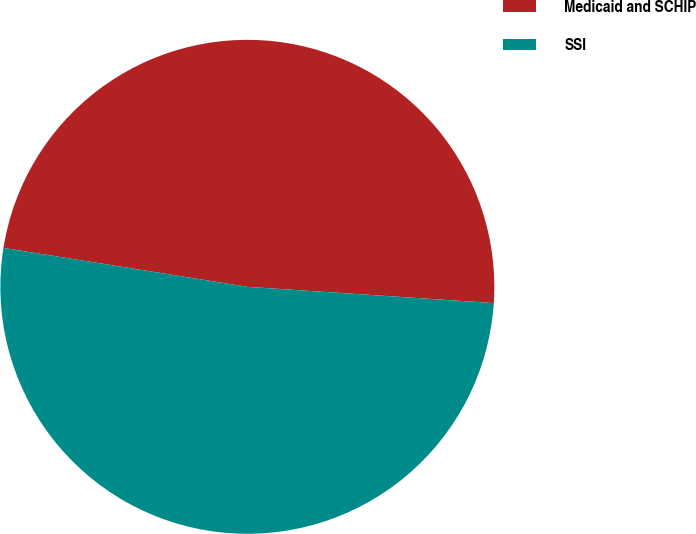<chart> <loc_0><loc_0><loc_500><loc_500><pie_chart><fcel>Medicaid and SCHIP<fcel>SSI<nl><fcel>48.53%<fcel>51.47%<nl></chart> 